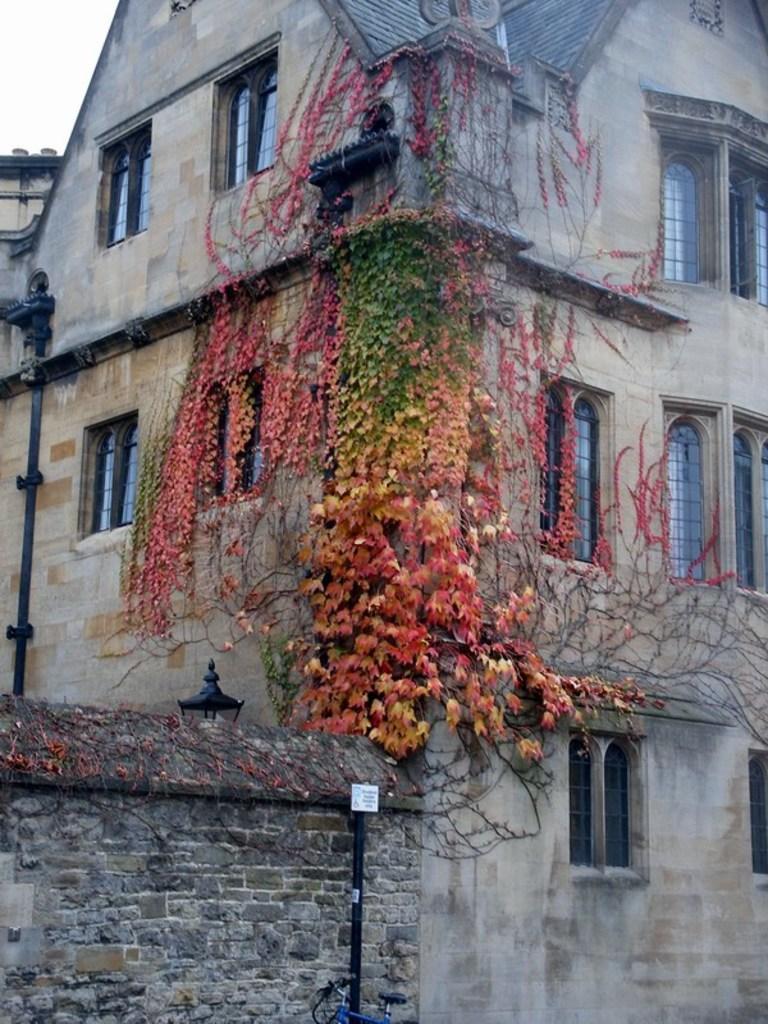Could you give a brief overview of what you see in this image? In the image there is a building, in front of the building there are branches of plants. 